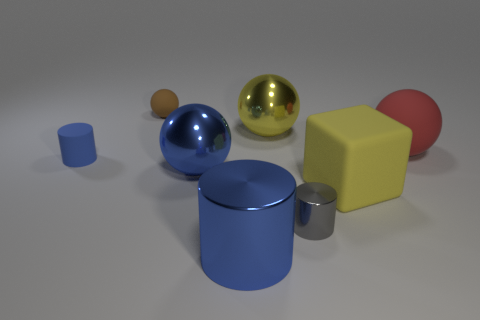The blue object to the left of the sphere in front of the object that is left of the small brown matte sphere is made of what material?
Make the answer very short. Rubber. Does the tiny thing on the left side of the brown matte object have the same material as the small cylinder that is in front of the large yellow block?
Ensure brevity in your answer.  No. There is a rubber object that is in front of the tiny brown rubber ball and to the left of the big cylinder; what size is it?
Give a very brief answer. Small. What material is the other cylinder that is the same size as the rubber cylinder?
Your response must be concise. Metal. There is a big yellow thing that is left of the tiny cylinder that is right of the brown rubber object; how many matte balls are on the left side of it?
Provide a succinct answer. 1. There is a large shiny sphere to the left of the yellow sphere; is its color the same as the shiny object that is in front of the gray metal cylinder?
Make the answer very short. Yes. What is the color of the tiny object that is in front of the small brown ball and behind the small gray cylinder?
Your response must be concise. Blue. How many brown rubber balls are the same size as the gray shiny cylinder?
Make the answer very short. 1. What shape is the big metal object that is left of the big blue thing in front of the blue sphere?
Offer a very short reply. Sphere. What shape is the yellow object in front of the thing that is to the left of the tiny matte thing behind the red object?
Provide a succinct answer. Cube. 